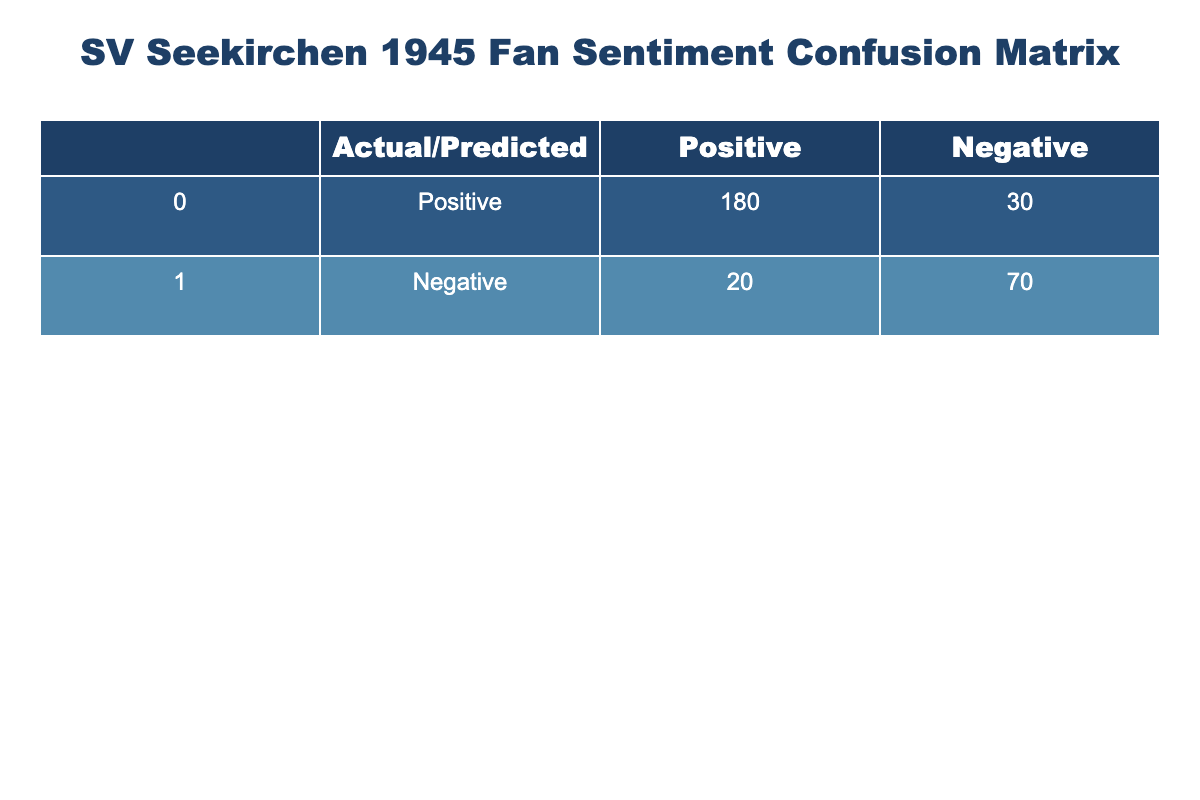What is the number of true positive predictions? The true positive predictions are found in the cell where actual sentiment is positive, and the predicted sentiment is also positive. Referring to the table, this value is 180.
Answer: 180 What is the number of true negative predictions? The true negative predictions are found where the actual sentiment is negative and the predicted sentiment is also negative. According to the table, this value is 70.
Answer: 70 What is the total number of negative sentiment predictions? The total negative sentiment predictions are the sum of true negatives and false negatives. From the table, true negatives are 70 and false negatives are 20. So, 70 + 20 = 90.
Answer: 90 Is the number of false positives greater than the number of true negatives? False positives are represented by the cell where actual sentiment is negative but predicted sentiment is positive, which is 20. True negatives are 70. Since 20 is not greater than 70, the answer is false.
Answer: No What is the accuracy of the model? Accuracy is calculated as the sum of true positives and true negatives divided by the total number of predictions. Here, the total predictions = 180 (true positive) + 30 (false positive) + 20 (false negative) + 70 (true negative) = 300. So accuracy = (180 + 70) / 300 = 250 / 300 = 0.83 or 83%.
Answer: 83% What is the number of misclassified positive sentiments? Misclassified (or false) positive sentiments are found where the actual sentiment is positive but predicted sentiment is negative. Looking at the table, this value is 30.
Answer: 30 What is the difference between the number of true positives and false negatives? To find the difference, we need to subtract the number of false negatives from true positives. So, this would be 180 (true positives) - 20 (false negatives) = 160.
Answer: 160 Are there more true positive predictions than false positive predictions? True positive predictions are 180 and false positive predictions are 30. Since 180 is greater than 30, the answer here is yes.
Answer: Yes What is the total count of predictions made by the model? The total count of predictions is the sum of all categories in the confusion matrix. Adding these values: 180 (true positive) + 30 (false positive) + 20 (false negative) + 70 (true negative) = 300 predictions in total.
Answer: 300 What is the proportion of true positives to total positive predictions? The proportion is defined as true positives divided by the total of true positives and false positives. So, this calculation is 180 (true positives) / (180 + 30) = 180 / 210 = 0.857 or 85.7%.
Answer: 85.7% 